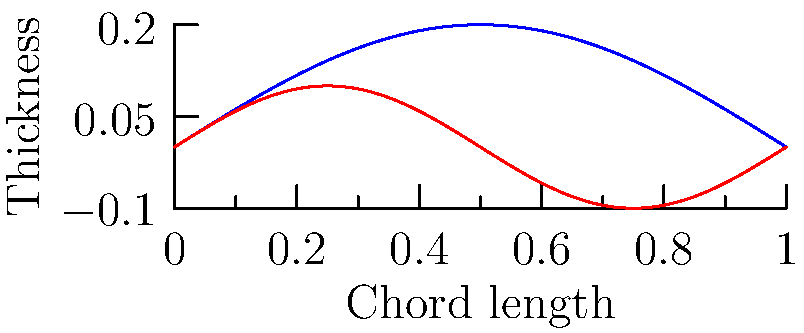As a leader seeking collaboration, understanding the principles of aerodynamics can be beneficial for various applications. Consider the two airfoil shapes shown in the graph. Which airfoil is likely to generate more lift at low angles of attack, and why would this be relevant for developing efficient transportation systems in your region? To answer this question, let's analyze the characteristics of the two airfoils:

1. Airfoil A (blue curve):
   - Has a larger maximum thickness
   - Has a more pronounced camber (curvature)

2. Airfoil B (red curve):
   - Has a smaller maximum thickness
   - Has less camber and more symmetrical shape

The lift generation of an airfoil depends on several factors, but at low angles of attack, the camber plays a crucial role. Here's why:

1. Camber effect: A more cambered airfoil (like Airfoil A) creates a greater pressure difference between the upper and lower surfaces, even at low angles of attack.

2. Circulation: The camber induces a larger circulation around the airfoil, which is directly related to lift according to the Kutta-Joukowski theorem: $L = \rho V \Gamma$, where $L$ is lift, $\rho$ is air density, $V$ is airspeed, and $\Gamma$ is circulation.

3. Pressure distribution: The cambered shape of Airfoil A leads to a more favorable pressure distribution, with lower pressure on the upper surface and higher pressure on the lower surface.

4. Thickness: While thickness does affect lift, its impact is less significant than camber at low angles of attack.

Therefore, Airfoil A is likely to generate more lift at low angles of attack.

Relevance for regional transportation:
1. Efficiency: Higher lift at low angles of attack means more efficient flight, reducing fuel consumption and operational costs.
2. Short takeoff and landing: Better lift characteristics allow for shorter runways, which can be beneficial in regions with limited infrastructure.
3. Slower flight capabilities: Enhanced lift at low speeds can improve safety and accessibility in mountainous or densely populated areas.
4. Economic impact: More efficient transportation systems can boost trade and connectivity between different ethnic groups, fostering collaboration and peaceful coexistence.
Answer: Airfoil A, due to its greater camber, generating higher lift at low angles of attack and promoting efficient, accessible transportation. 